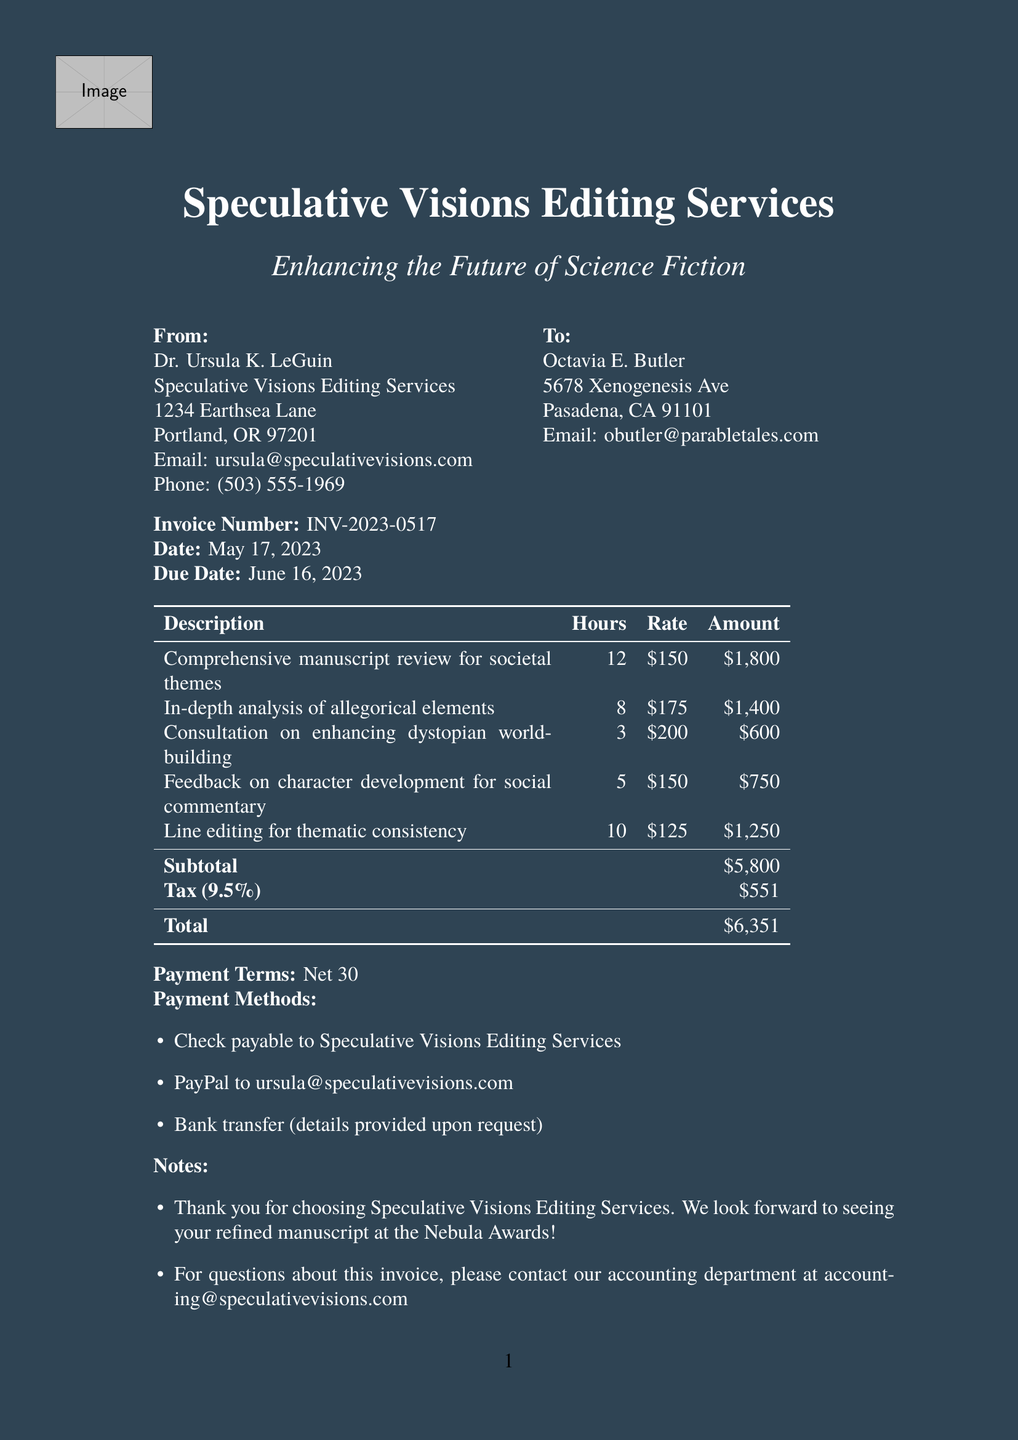What is the invoice number? The invoice number is a unique identifier for the invoice document.
Answer: INV-2023-0517 Who is the editor? The editor is the person or organization providing the editing services.
Answer: Dr. Ursula K. LeGuin What is the total amount due? The total amount due is the overall cost for the services provided, including taxes.
Answer: $6,351 How many hours were spent on line editing? The hours indicate the total time dedicated to a specific service outlined in the invoice.
Answer: 10 What is the payment term? The payment term specifies the conditions under which the payment is expected.
Answer: Net 30 What is the tax rate applied? The tax rate is the percentage applied to the subtotal to calculate the tax amount.
Answer: 9.5% What service received the highest hourly rate? This question looks for the service with the highest charge per hour based on the provided rates.
Answer: In-depth analysis of allegorical elements When is the payment due? The due date tells the client when the payment must be completed to avoid late fees.
Answer: June 16, 2023 What are the recommended resources? This refers to the additional materials suggested for further reading or learning related to the services provided.
Answer: Recommended reading: 'The Cambridge Companion to Science Fiction' by Edward James and Farah Mendlesohn 